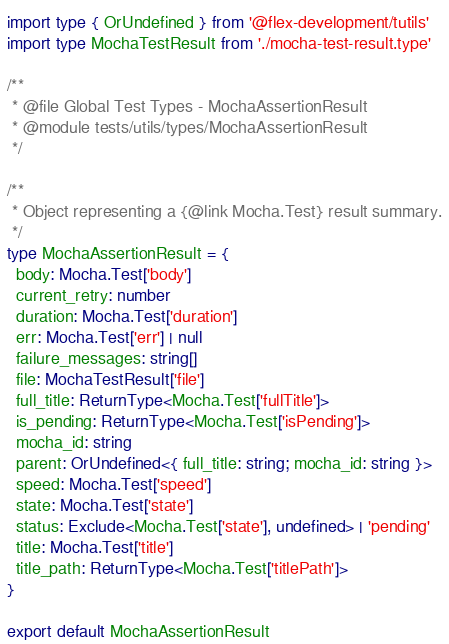<code> <loc_0><loc_0><loc_500><loc_500><_TypeScript_>import type { OrUndefined } from '@flex-development/tutils'
import type MochaTestResult from './mocha-test-result.type'

/**
 * @file Global Test Types - MochaAssertionResult
 * @module tests/utils/types/MochaAssertionResult
 */

/**
 * Object representing a {@link Mocha.Test} result summary.
 */
type MochaAssertionResult = {
  body: Mocha.Test['body']
  current_retry: number
  duration: Mocha.Test['duration']
  err: Mocha.Test['err'] | null
  failure_messages: string[]
  file: MochaTestResult['file']
  full_title: ReturnType<Mocha.Test['fullTitle']>
  is_pending: ReturnType<Mocha.Test['isPending']>
  mocha_id: string
  parent: OrUndefined<{ full_title: string; mocha_id: string }>
  speed: Mocha.Test['speed']
  state: Mocha.Test['state']
  status: Exclude<Mocha.Test['state'], undefined> | 'pending'
  title: Mocha.Test['title']
  title_path: ReturnType<Mocha.Test['titlePath']>
}

export default MochaAssertionResult
</code> 